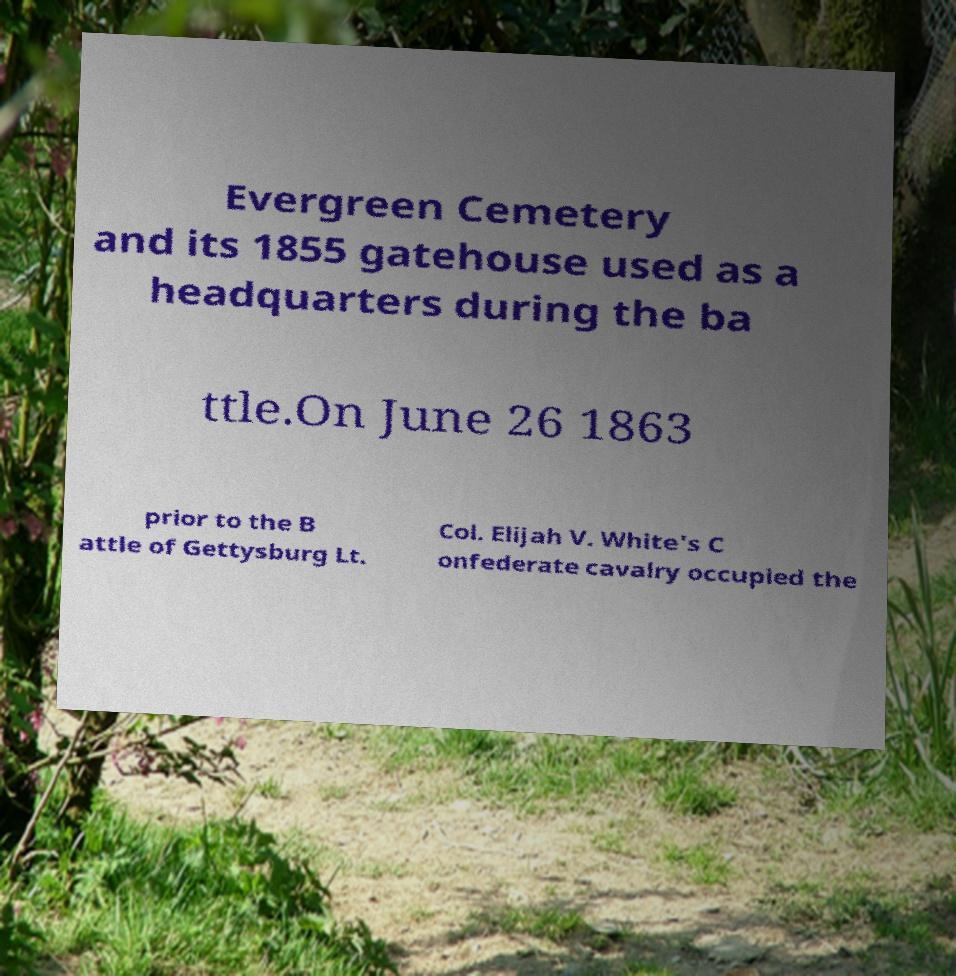Can you accurately transcribe the text from the provided image for me? Evergreen Cemetery and its 1855 gatehouse used as a headquarters during the ba ttle.On June 26 1863 prior to the B attle of Gettysburg Lt. Col. Elijah V. White's C onfederate cavalry occupied the 